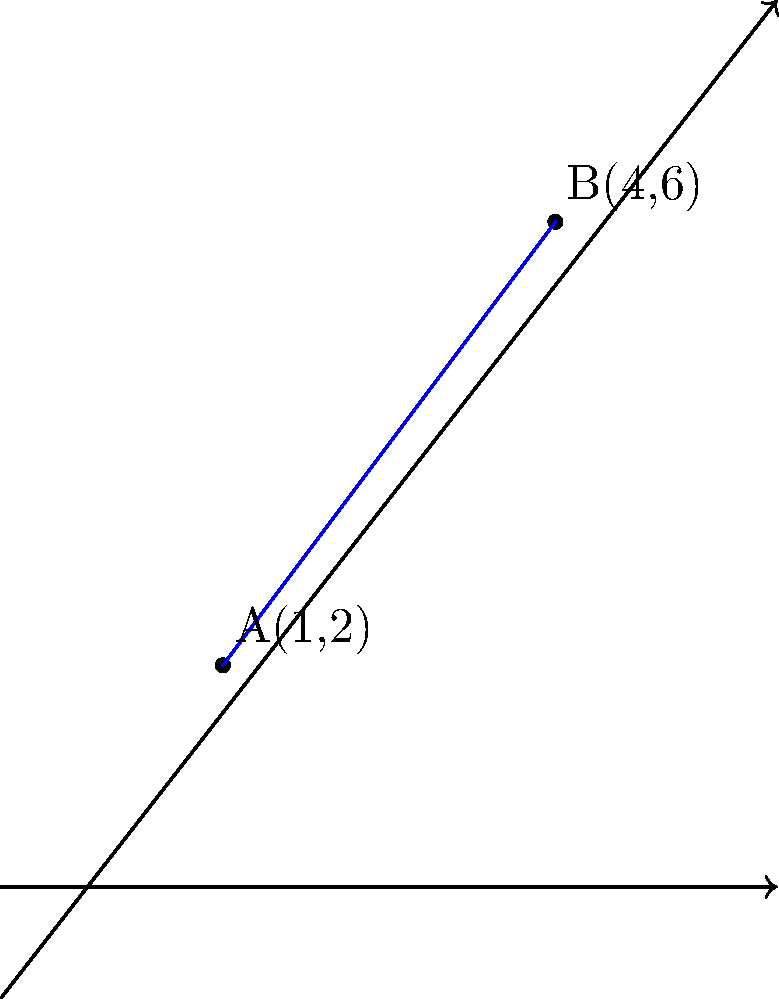As a senior .NET software developer working on a geometry-related project, you need to implement a function that calculates the equation of a line passing through two points in a 2D coordinate system. Given the points A(1,2) and B(4,6), determine the equation of the line in slope-intercept form (y = mx + b). What are the values of m (slope) and b (y-intercept)? To find the equation of the line passing through two points, we'll follow these steps:

1. Calculate the slope (m) using the slope formula:
   $$m = \frac{y_2 - y_1}{x_2 - x_1} = \frac{6 - 2}{4 - 1} = \frac{4}{3}$$

2. Use the point-slope form of a line with either point (let's use A(1,2)):
   $$y - y_1 = m(x - x_1)$$
   $$y - 2 = \frac{4}{3}(x - 1)$$

3. Expand the equation:
   $$y - 2 = \frac{4}{3}x - \frac{4}{3}$$

4. Solve for y to get the slope-intercept form (y = mx + b):
   $$y = \frac{4}{3}x - \frac{4}{3} + 2$$
   $$y = \frac{4}{3}x + \frac{2}{3}$$

Therefore, the slope (m) is $\frac{4}{3}$ and the y-intercept (b) is $\frac{2}{3}$.
Answer: m = $\frac{4}{3}$, b = $\frac{2}{3}$ 